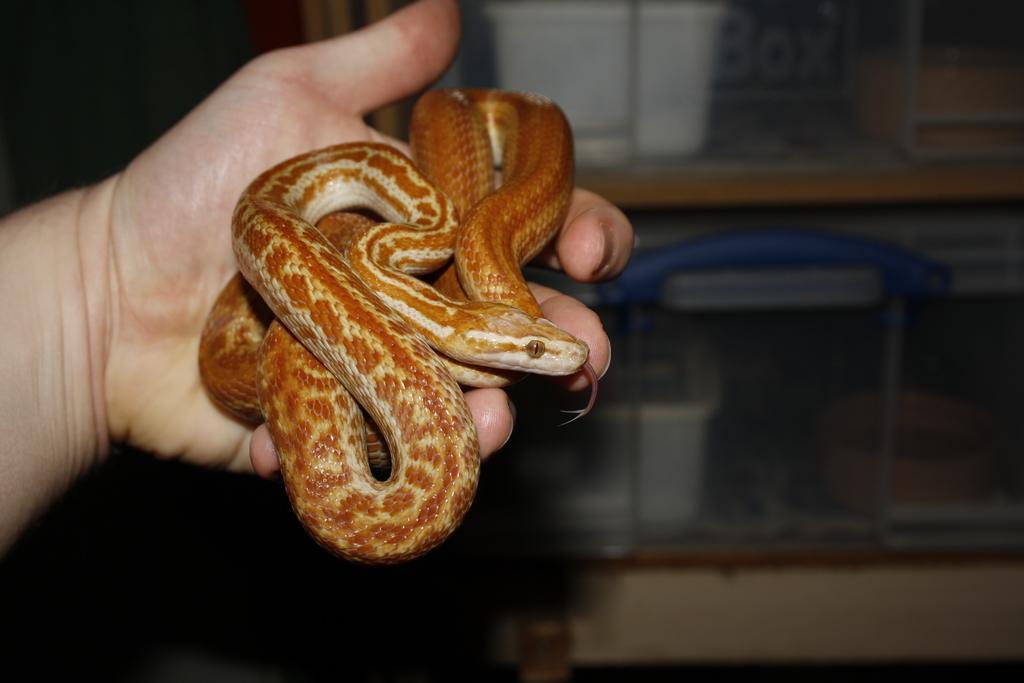How would you summarize this image in a sentence or two? In this picture there is a brown color snake in the person hand. Behind there is a wooden rack in which white color boxes are placed. 